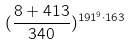<formula> <loc_0><loc_0><loc_500><loc_500>( \frac { 8 + 4 1 3 } { 3 4 0 } ) ^ { 1 9 1 ^ { 9 } \cdot 1 6 3 }</formula> 